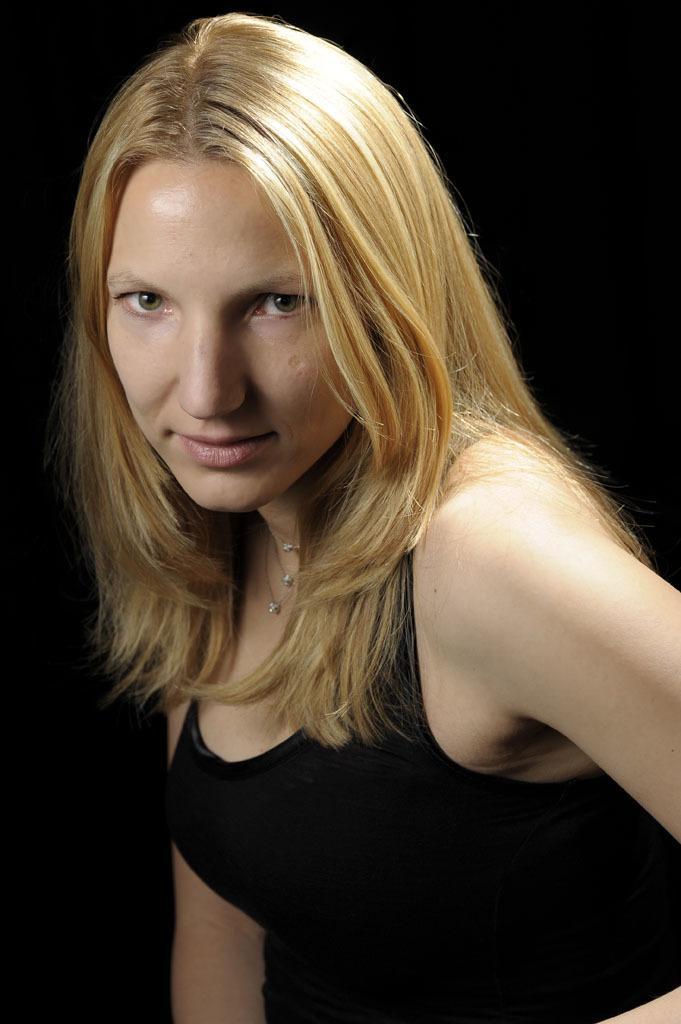Could you give a brief overview of what you see in this image? In this image, we can see a woman, she is wearing a black color dress. 